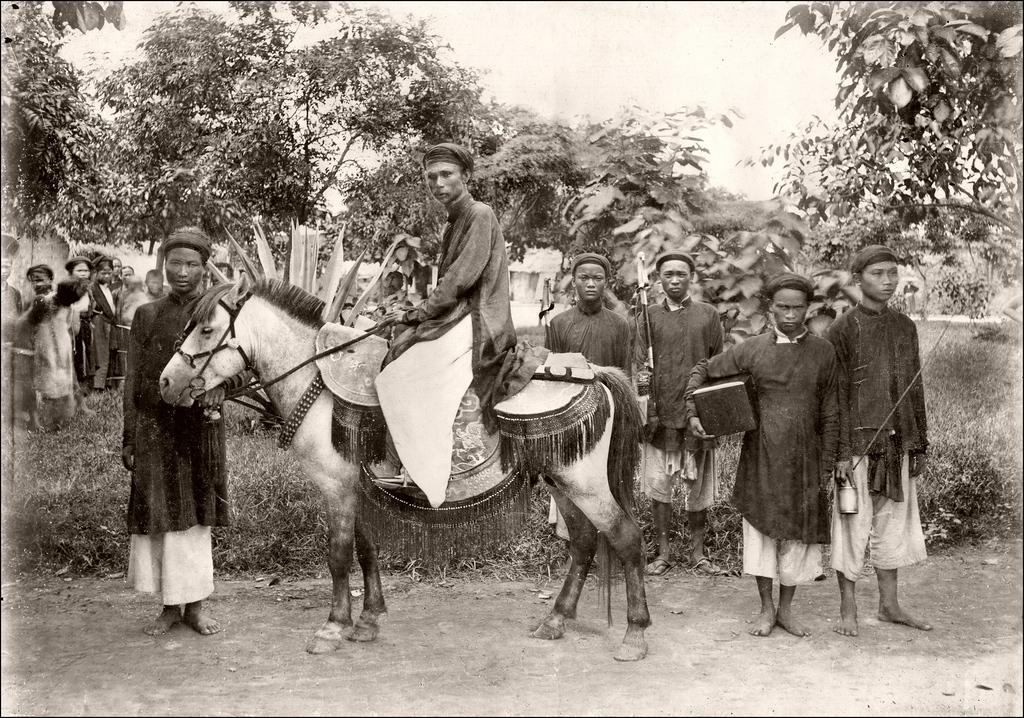How many people are present in the image? There are many people standing in the image. What is the person on the horse doing? The person standing on a horse is likely riding or controlling the horse. What type of vegetation can be seen in the image? There are plants visible in the image. What can be seen in the background of the image? There are trees in the background of the image. What type of cork can be seen in the image? There is no cork present in the image. What degree of difficulty is the person on the horse facing? The image does not provide information about the difficulty of the person's actions, nor does it mention any degrees of difficulty. 